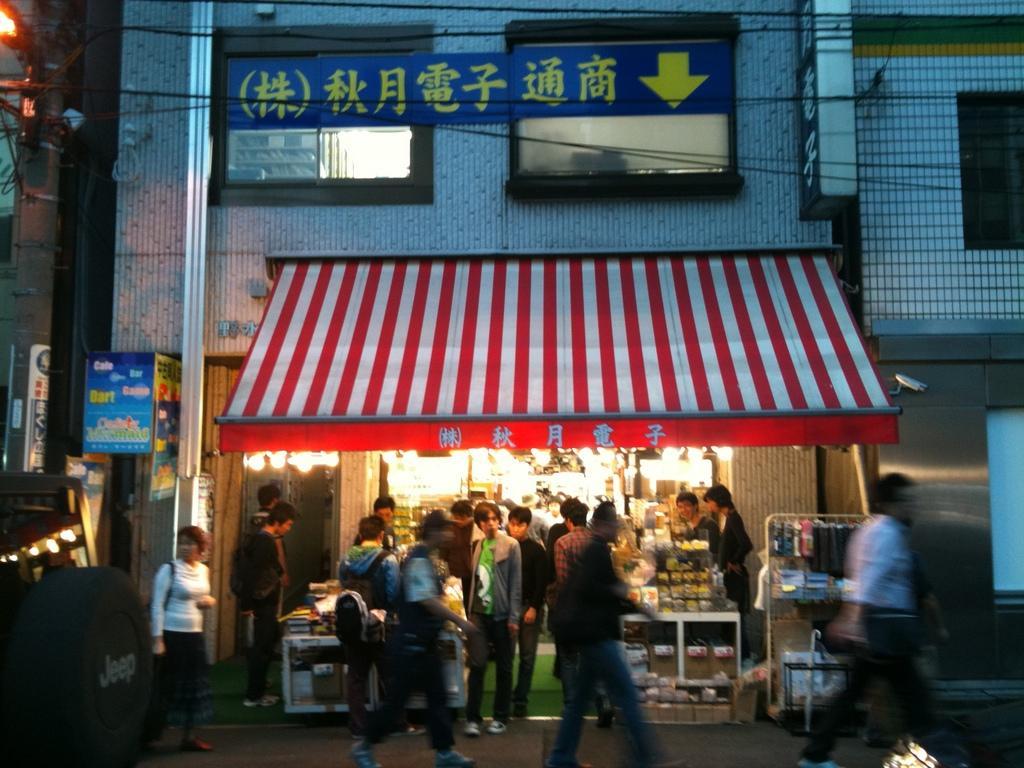Describe this image in one or two sentences. In the image we can see there are many people standing and some of them are walking, they are wearing clothes and shoes. We can see the store, pole, electric wires, building and the windows of the building. 